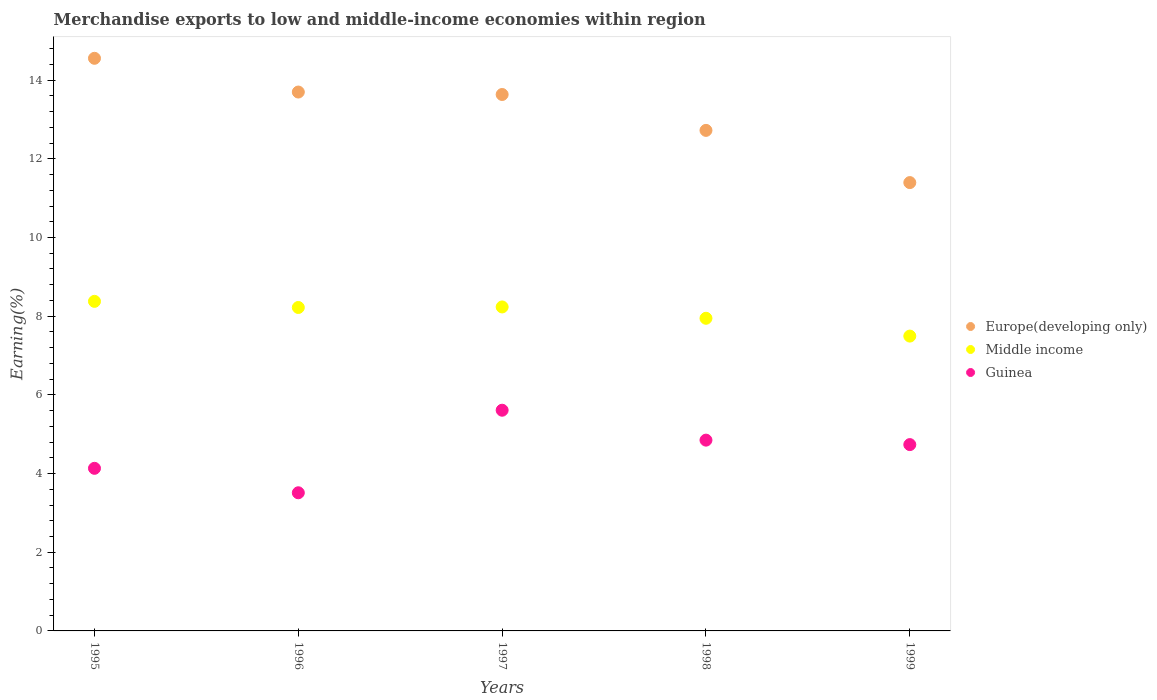How many different coloured dotlines are there?
Keep it short and to the point. 3. What is the percentage of amount earned from merchandise exports in Guinea in 1996?
Ensure brevity in your answer.  3.51. Across all years, what is the maximum percentage of amount earned from merchandise exports in Middle income?
Your response must be concise. 8.38. Across all years, what is the minimum percentage of amount earned from merchandise exports in Guinea?
Offer a terse response. 3.51. In which year was the percentage of amount earned from merchandise exports in Europe(developing only) maximum?
Give a very brief answer. 1995. In which year was the percentage of amount earned from merchandise exports in Guinea minimum?
Your response must be concise. 1996. What is the total percentage of amount earned from merchandise exports in Europe(developing only) in the graph?
Offer a terse response. 66.01. What is the difference between the percentage of amount earned from merchandise exports in Guinea in 1995 and that in 1998?
Provide a succinct answer. -0.72. What is the difference between the percentage of amount earned from merchandise exports in Middle income in 1997 and the percentage of amount earned from merchandise exports in Europe(developing only) in 1999?
Your answer should be very brief. -3.16. What is the average percentage of amount earned from merchandise exports in Middle income per year?
Your answer should be very brief. 8.06. In the year 1997, what is the difference between the percentage of amount earned from merchandise exports in Europe(developing only) and percentage of amount earned from merchandise exports in Middle income?
Provide a short and direct response. 5.4. In how many years, is the percentage of amount earned from merchandise exports in Guinea greater than 5.2 %?
Your answer should be very brief. 1. What is the ratio of the percentage of amount earned from merchandise exports in Guinea in 1996 to that in 1998?
Give a very brief answer. 0.72. What is the difference between the highest and the second highest percentage of amount earned from merchandise exports in Europe(developing only)?
Your answer should be very brief. 0.86. What is the difference between the highest and the lowest percentage of amount earned from merchandise exports in Guinea?
Ensure brevity in your answer.  2.1. In how many years, is the percentage of amount earned from merchandise exports in Guinea greater than the average percentage of amount earned from merchandise exports in Guinea taken over all years?
Offer a terse response. 3. Is the sum of the percentage of amount earned from merchandise exports in Europe(developing only) in 1996 and 1997 greater than the maximum percentage of amount earned from merchandise exports in Guinea across all years?
Give a very brief answer. Yes. Does the percentage of amount earned from merchandise exports in Middle income monotonically increase over the years?
Make the answer very short. No. Is the percentage of amount earned from merchandise exports in Europe(developing only) strictly less than the percentage of amount earned from merchandise exports in Guinea over the years?
Your response must be concise. No. Where does the legend appear in the graph?
Give a very brief answer. Center right. How are the legend labels stacked?
Your answer should be compact. Vertical. What is the title of the graph?
Offer a terse response. Merchandise exports to low and middle-income economies within region. Does "Dominica" appear as one of the legend labels in the graph?
Keep it short and to the point. No. What is the label or title of the X-axis?
Give a very brief answer. Years. What is the label or title of the Y-axis?
Your response must be concise. Earning(%). What is the Earning(%) in Europe(developing only) in 1995?
Keep it short and to the point. 14.56. What is the Earning(%) of Middle income in 1995?
Your answer should be very brief. 8.38. What is the Earning(%) in Guinea in 1995?
Provide a short and direct response. 4.13. What is the Earning(%) in Europe(developing only) in 1996?
Make the answer very short. 13.7. What is the Earning(%) in Middle income in 1996?
Make the answer very short. 8.22. What is the Earning(%) of Guinea in 1996?
Make the answer very short. 3.51. What is the Earning(%) in Europe(developing only) in 1997?
Your answer should be compact. 13.64. What is the Earning(%) of Middle income in 1997?
Keep it short and to the point. 8.24. What is the Earning(%) of Guinea in 1997?
Keep it short and to the point. 5.61. What is the Earning(%) in Europe(developing only) in 1998?
Offer a terse response. 12.72. What is the Earning(%) in Middle income in 1998?
Keep it short and to the point. 7.95. What is the Earning(%) in Guinea in 1998?
Keep it short and to the point. 4.85. What is the Earning(%) of Europe(developing only) in 1999?
Your response must be concise. 11.4. What is the Earning(%) in Middle income in 1999?
Your response must be concise. 7.49. What is the Earning(%) of Guinea in 1999?
Your answer should be very brief. 4.74. Across all years, what is the maximum Earning(%) in Europe(developing only)?
Keep it short and to the point. 14.56. Across all years, what is the maximum Earning(%) in Middle income?
Keep it short and to the point. 8.38. Across all years, what is the maximum Earning(%) in Guinea?
Your response must be concise. 5.61. Across all years, what is the minimum Earning(%) of Europe(developing only)?
Keep it short and to the point. 11.4. Across all years, what is the minimum Earning(%) in Middle income?
Your response must be concise. 7.49. Across all years, what is the minimum Earning(%) of Guinea?
Your answer should be compact. 3.51. What is the total Earning(%) of Europe(developing only) in the graph?
Make the answer very short. 66.01. What is the total Earning(%) of Middle income in the graph?
Provide a short and direct response. 40.28. What is the total Earning(%) in Guinea in the graph?
Your answer should be compact. 22.84. What is the difference between the Earning(%) of Europe(developing only) in 1995 and that in 1996?
Give a very brief answer. 0.86. What is the difference between the Earning(%) of Middle income in 1995 and that in 1996?
Offer a very short reply. 0.16. What is the difference between the Earning(%) of Guinea in 1995 and that in 1996?
Keep it short and to the point. 0.62. What is the difference between the Earning(%) of Europe(developing only) in 1995 and that in 1997?
Ensure brevity in your answer.  0.92. What is the difference between the Earning(%) of Middle income in 1995 and that in 1997?
Provide a short and direct response. 0.14. What is the difference between the Earning(%) of Guinea in 1995 and that in 1997?
Make the answer very short. -1.48. What is the difference between the Earning(%) of Europe(developing only) in 1995 and that in 1998?
Give a very brief answer. 1.83. What is the difference between the Earning(%) in Middle income in 1995 and that in 1998?
Your response must be concise. 0.43. What is the difference between the Earning(%) of Guinea in 1995 and that in 1998?
Provide a short and direct response. -0.72. What is the difference between the Earning(%) in Europe(developing only) in 1995 and that in 1999?
Keep it short and to the point. 3.16. What is the difference between the Earning(%) of Middle income in 1995 and that in 1999?
Your response must be concise. 0.88. What is the difference between the Earning(%) in Guinea in 1995 and that in 1999?
Offer a very short reply. -0.6. What is the difference between the Earning(%) of Europe(developing only) in 1996 and that in 1997?
Your response must be concise. 0.06. What is the difference between the Earning(%) in Middle income in 1996 and that in 1997?
Your answer should be compact. -0.01. What is the difference between the Earning(%) in Guinea in 1996 and that in 1997?
Ensure brevity in your answer.  -2.1. What is the difference between the Earning(%) in Europe(developing only) in 1996 and that in 1998?
Your answer should be compact. 0.97. What is the difference between the Earning(%) in Middle income in 1996 and that in 1998?
Your response must be concise. 0.27. What is the difference between the Earning(%) in Guinea in 1996 and that in 1998?
Offer a terse response. -1.34. What is the difference between the Earning(%) of Europe(developing only) in 1996 and that in 1999?
Give a very brief answer. 2.3. What is the difference between the Earning(%) in Middle income in 1996 and that in 1999?
Offer a terse response. 0.73. What is the difference between the Earning(%) of Guinea in 1996 and that in 1999?
Make the answer very short. -1.22. What is the difference between the Earning(%) of Europe(developing only) in 1997 and that in 1998?
Make the answer very short. 0.91. What is the difference between the Earning(%) of Middle income in 1997 and that in 1998?
Keep it short and to the point. 0.29. What is the difference between the Earning(%) in Guinea in 1997 and that in 1998?
Provide a succinct answer. 0.76. What is the difference between the Earning(%) of Europe(developing only) in 1997 and that in 1999?
Provide a short and direct response. 2.24. What is the difference between the Earning(%) in Middle income in 1997 and that in 1999?
Keep it short and to the point. 0.74. What is the difference between the Earning(%) of Guinea in 1997 and that in 1999?
Give a very brief answer. 0.87. What is the difference between the Earning(%) in Europe(developing only) in 1998 and that in 1999?
Offer a terse response. 1.33. What is the difference between the Earning(%) in Middle income in 1998 and that in 1999?
Offer a very short reply. 0.45. What is the difference between the Earning(%) in Guinea in 1998 and that in 1999?
Ensure brevity in your answer.  0.11. What is the difference between the Earning(%) in Europe(developing only) in 1995 and the Earning(%) in Middle income in 1996?
Ensure brevity in your answer.  6.33. What is the difference between the Earning(%) in Europe(developing only) in 1995 and the Earning(%) in Guinea in 1996?
Give a very brief answer. 11.04. What is the difference between the Earning(%) of Middle income in 1995 and the Earning(%) of Guinea in 1996?
Provide a succinct answer. 4.87. What is the difference between the Earning(%) of Europe(developing only) in 1995 and the Earning(%) of Middle income in 1997?
Keep it short and to the point. 6.32. What is the difference between the Earning(%) in Europe(developing only) in 1995 and the Earning(%) in Guinea in 1997?
Offer a very short reply. 8.95. What is the difference between the Earning(%) of Middle income in 1995 and the Earning(%) of Guinea in 1997?
Your answer should be compact. 2.77. What is the difference between the Earning(%) in Europe(developing only) in 1995 and the Earning(%) in Middle income in 1998?
Offer a terse response. 6.61. What is the difference between the Earning(%) in Europe(developing only) in 1995 and the Earning(%) in Guinea in 1998?
Your answer should be very brief. 9.71. What is the difference between the Earning(%) in Middle income in 1995 and the Earning(%) in Guinea in 1998?
Your response must be concise. 3.53. What is the difference between the Earning(%) in Europe(developing only) in 1995 and the Earning(%) in Middle income in 1999?
Your answer should be compact. 7.06. What is the difference between the Earning(%) of Europe(developing only) in 1995 and the Earning(%) of Guinea in 1999?
Your response must be concise. 9.82. What is the difference between the Earning(%) of Middle income in 1995 and the Earning(%) of Guinea in 1999?
Make the answer very short. 3.64. What is the difference between the Earning(%) of Europe(developing only) in 1996 and the Earning(%) of Middle income in 1997?
Keep it short and to the point. 5.46. What is the difference between the Earning(%) in Europe(developing only) in 1996 and the Earning(%) in Guinea in 1997?
Keep it short and to the point. 8.09. What is the difference between the Earning(%) of Middle income in 1996 and the Earning(%) of Guinea in 1997?
Your answer should be very brief. 2.61. What is the difference between the Earning(%) in Europe(developing only) in 1996 and the Earning(%) in Middle income in 1998?
Provide a short and direct response. 5.75. What is the difference between the Earning(%) in Europe(developing only) in 1996 and the Earning(%) in Guinea in 1998?
Provide a succinct answer. 8.85. What is the difference between the Earning(%) of Middle income in 1996 and the Earning(%) of Guinea in 1998?
Keep it short and to the point. 3.37. What is the difference between the Earning(%) in Europe(developing only) in 1996 and the Earning(%) in Middle income in 1999?
Your response must be concise. 6.2. What is the difference between the Earning(%) of Europe(developing only) in 1996 and the Earning(%) of Guinea in 1999?
Your answer should be compact. 8.96. What is the difference between the Earning(%) of Middle income in 1996 and the Earning(%) of Guinea in 1999?
Make the answer very short. 3.49. What is the difference between the Earning(%) of Europe(developing only) in 1997 and the Earning(%) of Middle income in 1998?
Keep it short and to the point. 5.69. What is the difference between the Earning(%) of Europe(developing only) in 1997 and the Earning(%) of Guinea in 1998?
Give a very brief answer. 8.79. What is the difference between the Earning(%) of Middle income in 1997 and the Earning(%) of Guinea in 1998?
Ensure brevity in your answer.  3.39. What is the difference between the Earning(%) of Europe(developing only) in 1997 and the Earning(%) of Middle income in 1999?
Provide a succinct answer. 6.14. What is the difference between the Earning(%) of Europe(developing only) in 1997 and the Earning(%) of Guinea in 1999?
Your answer should be very brief. 8.9. What is the difference between the Earning(%) of Middle income in 1997 and the Earning(%) of Guinea in 1999?
Provide a succinct answer. 3.5. What is the difference between the Earning(%) in Europe(developing only) in 1998 and the Earning(%) in Middle income in 1999?
Ensure brevity in your answer.  5.23. What is the difference between the Earning(%) in Europe(developing only) in 1998 and the Earning(%) in Guinea in 1999?
Give a very brief answer. 7.99. What is the difference between the Earning(%) of Middle income in 1998 and the Earning(%) of Guinea in 1999?
Provide a short and direct response. 3.21. What is the average Earning(%) in Europe(developing only) per year?
Provide a short and direct response. 13.2. What is the average Earning(%) in Middle income per year?
Offer a terse response. 8.06. What is the average Earning(%) of Guinea per year?
Your response must be concise. 4.57. In the year 1995, what is the difference between the Earning(%) in Europe(developing only) and Earning(%) in Middle income?
Make the answer very short. 6.18. In the year 1995, what is the difference between the Earning(%) in Europe(developing only) and Earning(%) in Guinea?
Offer a terse response. 10.42. In the year 1995, what is the difference between the Earning(%) of Middle income and Earning(%) of Guinea?
Offer a terse response. 4.24. In the year 1996, what is the difference between the Earning(%) of Europe(developing only) and Earning(%) of Middle income?
Offer a terse response. 5.48. In the year 1996, what is the difference between the Earning(%) of Europe(developing only) and Earning(%) of Guinea?
Your answer should be very brief. 10.19. In the year 1996, what is the difference between the Earning(%) of Middle income and Earning(%) of Guinea?
Offer a terse response. 4.71. In the year 1997, what is the difference between the Earning(%) in Europe(developing only) and Earning(%) in Middle income?
Your answer should be compact. 5.4. In the year 1997, what is the difference between the Earning(%) of Europe(developing only) and Earning(%) of Guinea?
Offer a very short reply. 8.03. In the year 1997, what is the difference between the Earning(%) in Middle income and Earning(%) in Guinea?
Provide a short and direct response. 2.63. In the year 1998, what is the difference between the Earning(%) of Europe(developing only) and Earning(%) of Middle income?
Your response must be concise. 4.78. In the year 1998, what is the difference between the Earning(%) in Europe(developing only) and Earning(%) in Guinea?
Give a very brief answer. 7.87. In the year 1998, what is the difference between the Earning(%) of Middle income and Earning(%) of Guinea?
Offer a very short reply. 3.1. In the year 1999, what is the difference between the Earning(%) in Europe(developing only) and Earning(%) in Middle income?
Your answer should be very brief. 3.9. In the year 1999, what is the difference between the Earning(%) of Europe(developing only) and Earning(%) of Guinea?
Offer a terse response. 6.66. In the year 1999, what is the difference between the Earning(%) of Middle income and Earning(%) of Guinea?
Ensure brevity in your answer.  2.76. What is the ratio of the Earning(%) in Europe(developing only) in 1995 to that in 1996?
Your response must be concise. 1.06. What is the ratio of the Earning(%) of Middle income in 1995 to that in 1996?
Your answer should be very brief. 1.02. What is the ratio of the Earning(%) in Guinea in 1995 to that in 1996?
Ensure brevity in your answer.  1.18. What is the ratio of the Earning(%) in Europe(developing only) in 1995 to that in 1997?
Provide a succinct answer. 1.07. What is the ratio of the Earning(%) of Middle income in 1995 to that in 1997?
Make the answer very short. 1.02. What is the ratio of the Earning(%) in Guinea in 1995 to that in 1997?
Keep it short and to the point. 0.74. What is the ratio of the Earning(%) of Europe(developing only) in 1995 to that in 1998?
Your response must be concise. 1.14. What is the ratio of the Earning(%) in Middle income in 1995 to that in 1998?
Keep it short and to the point. 1.05. What is the ratio of the Earning(%) of Guinea in 1995 to that in 1998?
Provide a succinct answer. 0.85. What is the ratio of the Earning(%) in Europe(developing only) in 1995 to that in 1999?
Your answer should be very brief. 1.28. What is the ratio of the Earning(%) of Middle income in 1995 to that in 1999?
Your response must be concise. 1.12. What is the ratio of the Earning(%) in Guinea in 1995 to that in 1999?
Offer a terse response. 0.87. What is the ratio of the Earning(%) of Guinea in 1996 to that in 1997?
Your answer should be compact. 0.63. What is the ratio of the Earning(%) of Europe(developing only) in 1996 to that in 1998?
Your answer should be compact. 1.08. What is the ratio of the Earning(%) of Middle income in 1996 to that in 1998?
Give a very brief answer. 1.03. What is the ratio of the Earning(%) of Guinea in 1996 to that in 1998?
Provide a succinct answer. 0.72. What is the ratio of the Earning(%) in Europe(developing only) in 1996 to that in 1999?
Provide a succinct answer. 1.2. What is the ratio of the Earning(%) in Middle income in 1996 to that in 1999?
Your answer should be compact. 1.1. What is the ratio of the Earning(%) in Guinea in 1996 to that in 1999?
Provide a short and direct response. 0.74. What is the ratio of the Earning(%) of Europe(developing only) in 1997 to that in 1998?
Keep it short and to the point. 1.07. What is the ratio of the Earning(%) of Middle income in 1997 to that in 1998?
Give a very brief answer. 1.04. What is the ratio of the Earning(%) in Guinea in 1997 to that in 1998?
Give a very brief answer. 1.16. What is the ratio of the Earning(%) of Europe(developing only) in 1997 to that in 1999?
Your answer should be very brief. 1.2. What is the ratio of the Earning(%) in Middle income in 1997 to that in 1999?
Keep it short and to the point. 1.1. What is the ratio of the Earning(%) of Guinea in 1997 to that in 1999?
Provide a short and direct response. 1.18. What is the ratio of the Earning(%) of Europe(developing only) in 1998 to that in 1999?
Provide a short and direct response. 1.12. What is the ratio of the Earning(%) in Middle income in 1998 to that in 1999?
Offer a terse response. 1.06. What is the difference between the highest and the second highest Earning(%) in Europe(developing only)?
Provide a succinct answer. 0.86. What is the difference between the highest and the second highest Earning(%) in Middle income?
Offer a terse response. 0.14. What is the difference between the highest and the second highest Earning(%) in Guinea?
Your response must be concise. 0.76. What is the difference between the highest and the lowest Earning(%) in Europe(developing only)?
Provide a succinct answer. 3.16. What is the difference between the highest and the lowest Earning(%) of Middle income?
Keep it short and to the point. 0.88. What is the difference between the highest and the lowest Earning(%) of Guinea?
Offer a very short reply. 2.1. 